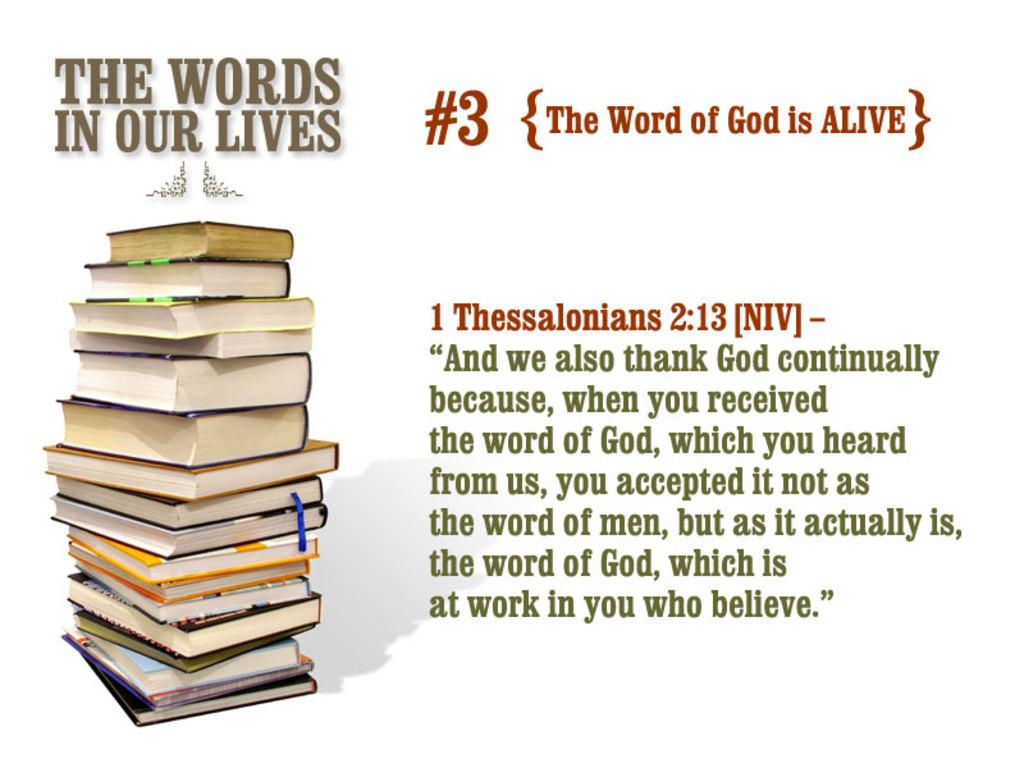<image>
Share a concise interpretation of the image provided. A stack of books with a Bible quote next to it from Thessalonians. 